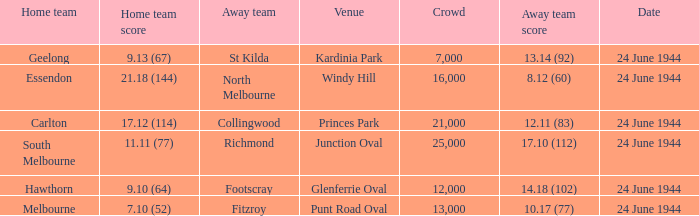When Essendon was the Home Team, what was the Away Team score? 8.12 (60). Parse the full table. {'header': ['Home team', 'Home team score', 'Away team', 'Venue', 'Crowd', 'Away team score', 'Date'], 'rows': [['Geelong', '9.13 (67)', 'St Kilda', 'Kardinia Park', '7,000', '13.14 (92)', '24 June 1944'], ['Essendon', '21.18 (144)', 'North Melbourne', 'Windy Hill', '16,000', '8.12 (60)', '24 June 1944'], ['Carlton', '17.12 (114)', 'Collingwood', 'Princes Park', '21,000', '12.11 (83)', '24 June 1944'], ['South Melbourne', '11.11 (77)', 'Richmond', 'Junction Oval', '25,000', '17.10 (112)', '24 June 1944'], ['Hawthorn', '9.10 (64)', 'Footscray', 'Glenferrie Oval', '12,000', '14.18 (102)', '24 June 1944'], ['Melbourne', '7.10 (52)', 'Fitzroy', 'Punt Road Oval', '13,000', '10.17 (77)', '24 June 1944']]} 